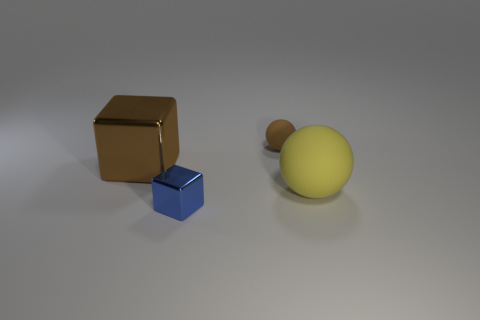Add 1 big yellow rubber objects. How many objects exist? 5 Add 1 tiny brown balls. How many tiny brown balls exist? 2 Subtract 0 purple blocks. How many objects are left? 4 Subtract all large purple cylinders. Subtract all large rubber objects. How many objects are left? 3 Add 4 large spheres. How many large spheres are left? 5 